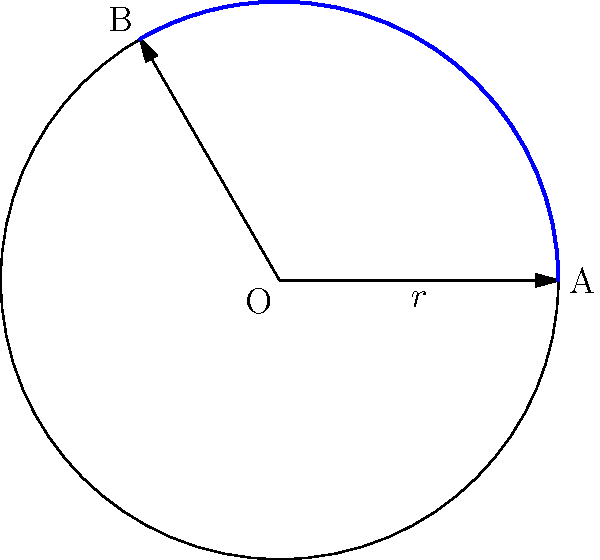At your former workplace in the Clouth Gummiwerke factory, you encounter a circular rubber gasket with a radius of 12 cm. If the central angle of a sector of this gasket is 120°, what is the area of this sector in square centimeters? To find the area of a sector of a circle, we can follow these steps:

1) The formula for the area of a sector is:

   $$A = \frac{1}{2}r^2\theta$$

   where $A$ is the area, $r$ is the radius, and $\theta$ is the central angle in radians.

2) We are given the radius $r = 12$ cm and the angle in degrees (120°).

3) First, we need to convert the angle from degrees to radians:

   $$\theta = 120° \times \frac{\pi}{180°} = \frac{2\pi}{3} \approx 2.0944$$

4) Now we can substitute these values into our formula:

   $$A = \frac{1}{2} \times 12^2 \times \frac{2\pi}{3}$$

5) Simplify:

   $$A = 6 \times 12 \times \frac{2\pi}{3} = 48\pi$$

6) If we want to approximate this to a decimal:

   $$A \approx 150.80 \text{ cm}^2$$

Therefore, the area of the sector is $48\pi$ square centimeters, or approximately 150.80 square centimeters.
Answer: $48\pi \text{ cm}^2$ 